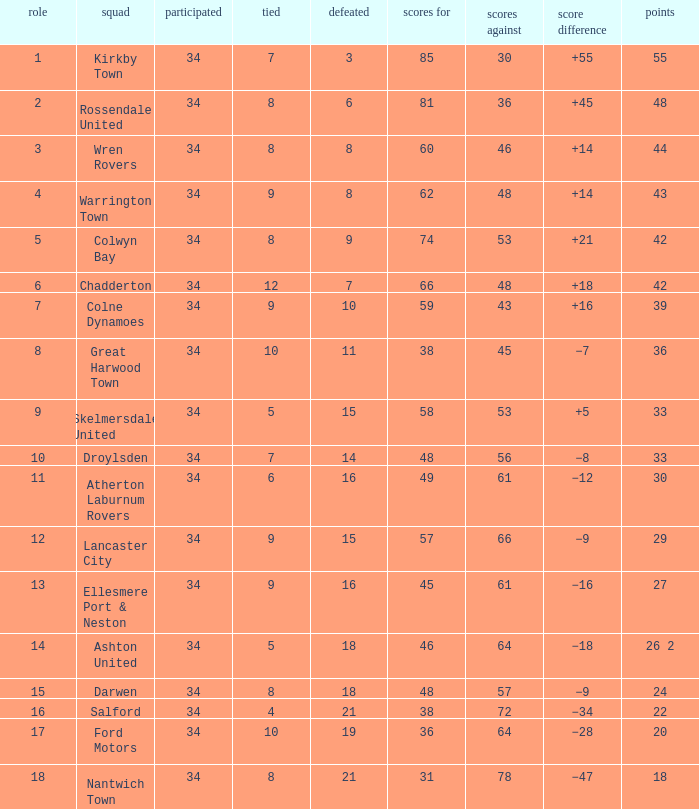What is the smallest number of goals against when there are 1 of 18 points, and more than 8 are drawn? None. 